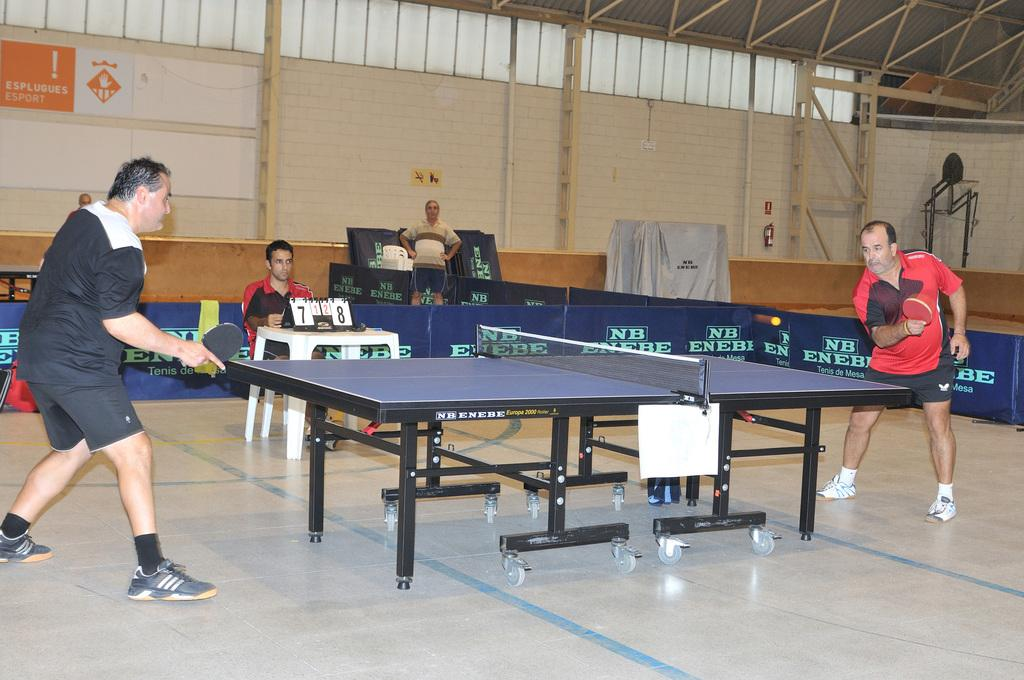What activity are the two persons engaged in? The two persons are playing table tennis. Can you describe the position of the third person in the image? There is a man sitting in the middle. What type of cloth is the sister using to wipe the table tennis table? There is no mention of a sister or a cloth in the image, so we cannot answer this question. 